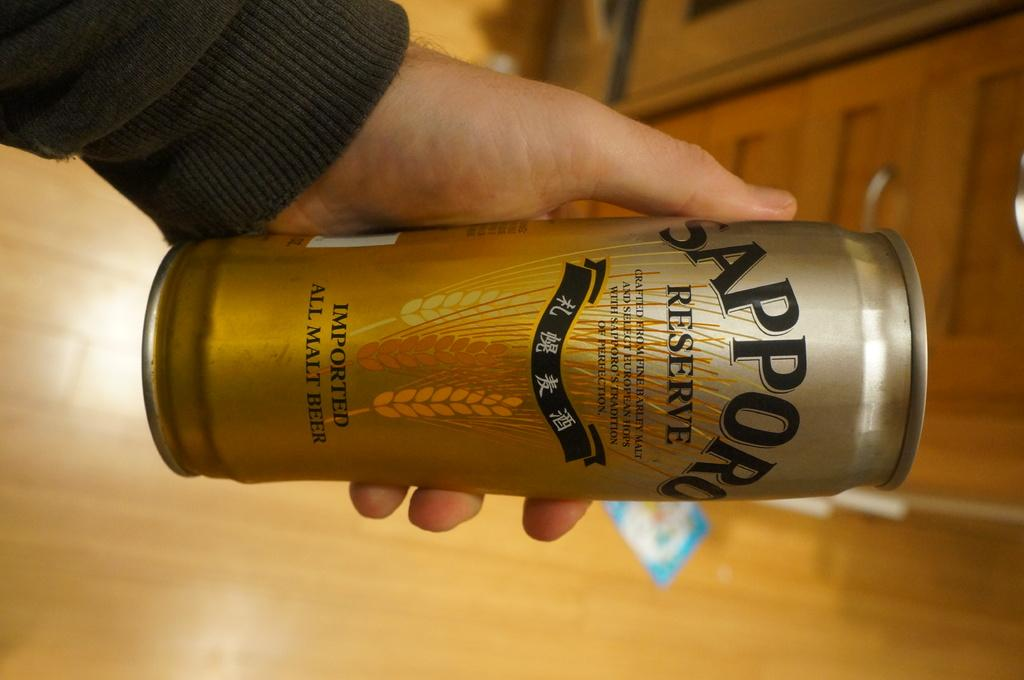<image>
Relay a brief, clear account of the picture shown. A hand holds a gold bottle of Sapporo Reserve. 